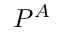Convert formula to latex. <formula><loc_0><loc_0><loc_500><loc_500>P ^ { A }</formula> 